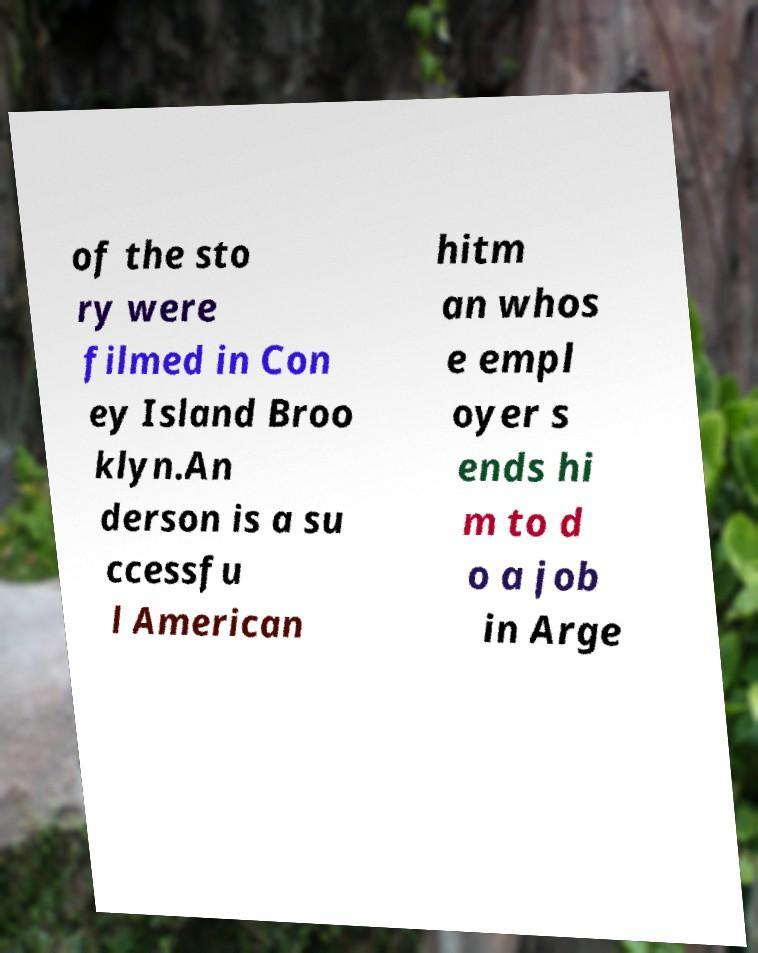Please read and relay the text visible in this image. What does it say? of the sto ry were filmed in Con ey Island Broo klyn.An derson is a su ccessfu l American hitm an whos e empl oyer s ends hi m to d o a job in Arge 